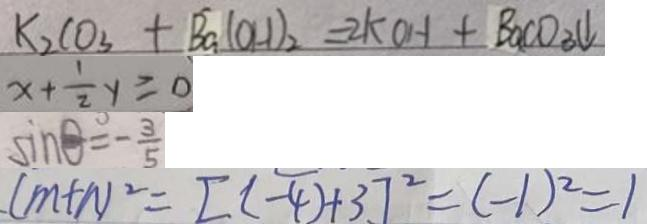<formula> <loc_0><loc_0><loc_500><loc_500>K _ { 2 } C O _ { 3 } + B a ( O H ) _ { 2 } = 2 k O H + B a C O _ { 3 } \downarrow 
 x + \frac { 1 } { 2 } y \geq 0 
 \sin \theta ^ { \circ } = - \frac { 3 } { 5 } 
 ( m + n ) ^ { 2 } = [ ( - 4 ) + 3 ] ^ { 2 } = ( - 1 ) ^ { 2 } = 1</formula> 